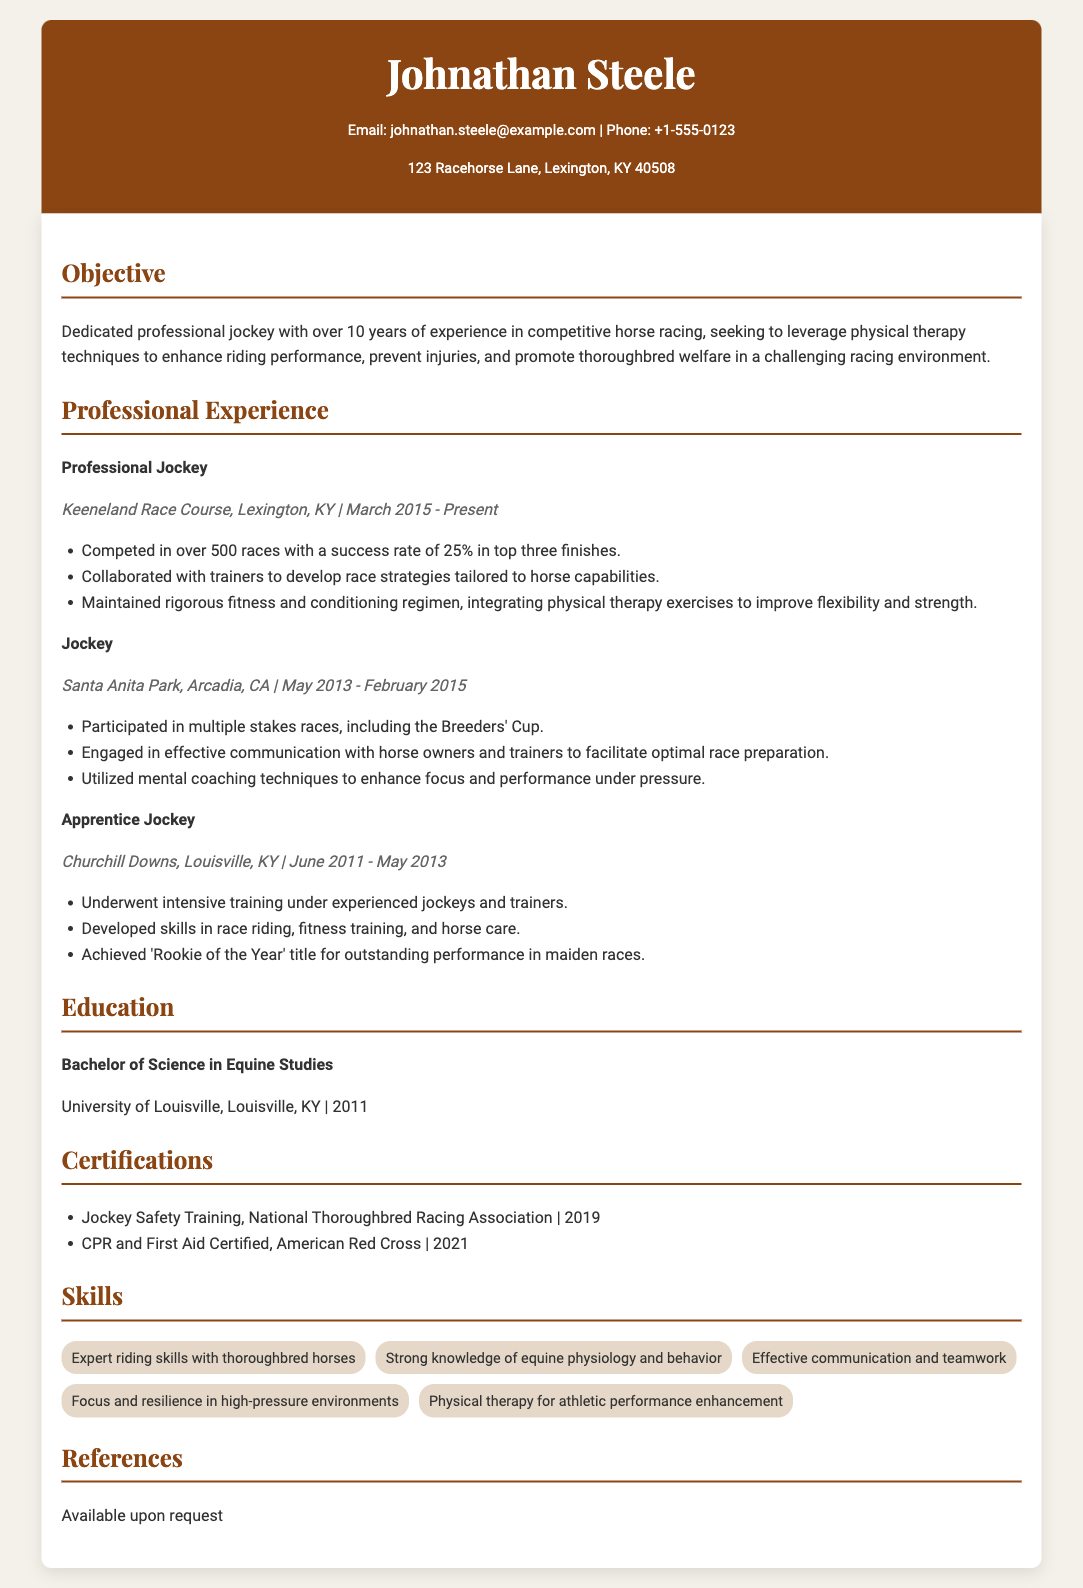What is the name of the jockey? The name of the jockey is prominently displayed in the header section of the document.
Answer: Johnathan Steele What is the contact email provided? The email is listed in the contact information section.
Answer: johnathan.steele@example.com How many years of experience does the jockey have? The objective section states that the jockey has over 10 years of experience.
Answer: 10 years What is the current job title of Johnathan Steele? The job title can be found in the Professional Experience section.
Answer: Professional Jockey In which race course does Johnathan currently work? The job details for his current position indicate the location of his work.
Answer: Keeneland Race Course What percentage of success rate does Johnathan have in top three finishes? This detail is included in the job description of his current role.
Answer: 25% What title did Johnathan achieve as an Apprentice Jockey? This achievement is noted in the duties listed under his Apprentice Jockey position.
Answer: Rookie of the Year Which certification was obtained in 2021? The certifications section lists the year specific certifications were achieved.
Answer: CPR and First Aid Certified What degree did Johnathan earn? The Education section specifies the degree obtained by Johnathan.
Answer: Bachelor of Science in Equine Studies What skill related to athletic performance enhancement is mentioned? The Skills section lists specific skills related to his profession.
Answer: Physical therapy for athletic performance enhancement 